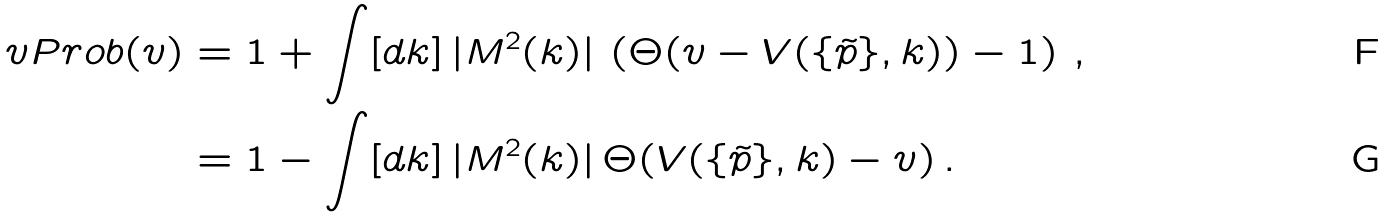<formula> <loc_0><loc_0><loc_500><loc_500>\ v P r o b ( v ) & = 1 + \int [ d k ] \, | M ^ { 2 } ( k ) | \, \left ( \Theta ( v - V ( \{ \tilde { p } \} , k ) ) - 1 \right ) \, , \\ & = 1 - \int [ d k ] \, | M ^ { 2 } ( k ) | \, \Theta ( V ( \{ \tilde { p } \} , k ) - v ) \, .</formula> 